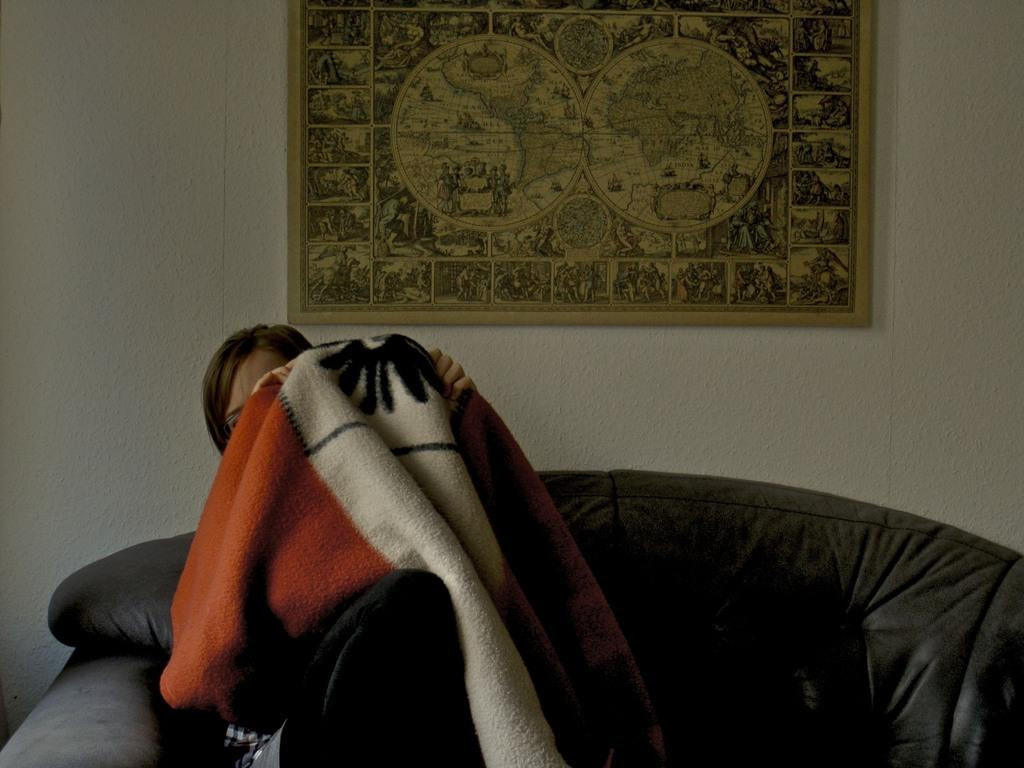Who is present in the image? There is a woman in the image. What is the woman holding in the image? The woman is holding a blanket. What is the woman sitting on in the image? The woman is sitting on a chair. What can be seen in the background of the image? There is a wall in the background of the image. What other object is visible in the image? There is a photo frame in the image. What type of shoe is the woman wearing in the image? There is no shoe visible in the image; the woman is sitting and holding a blanket. 